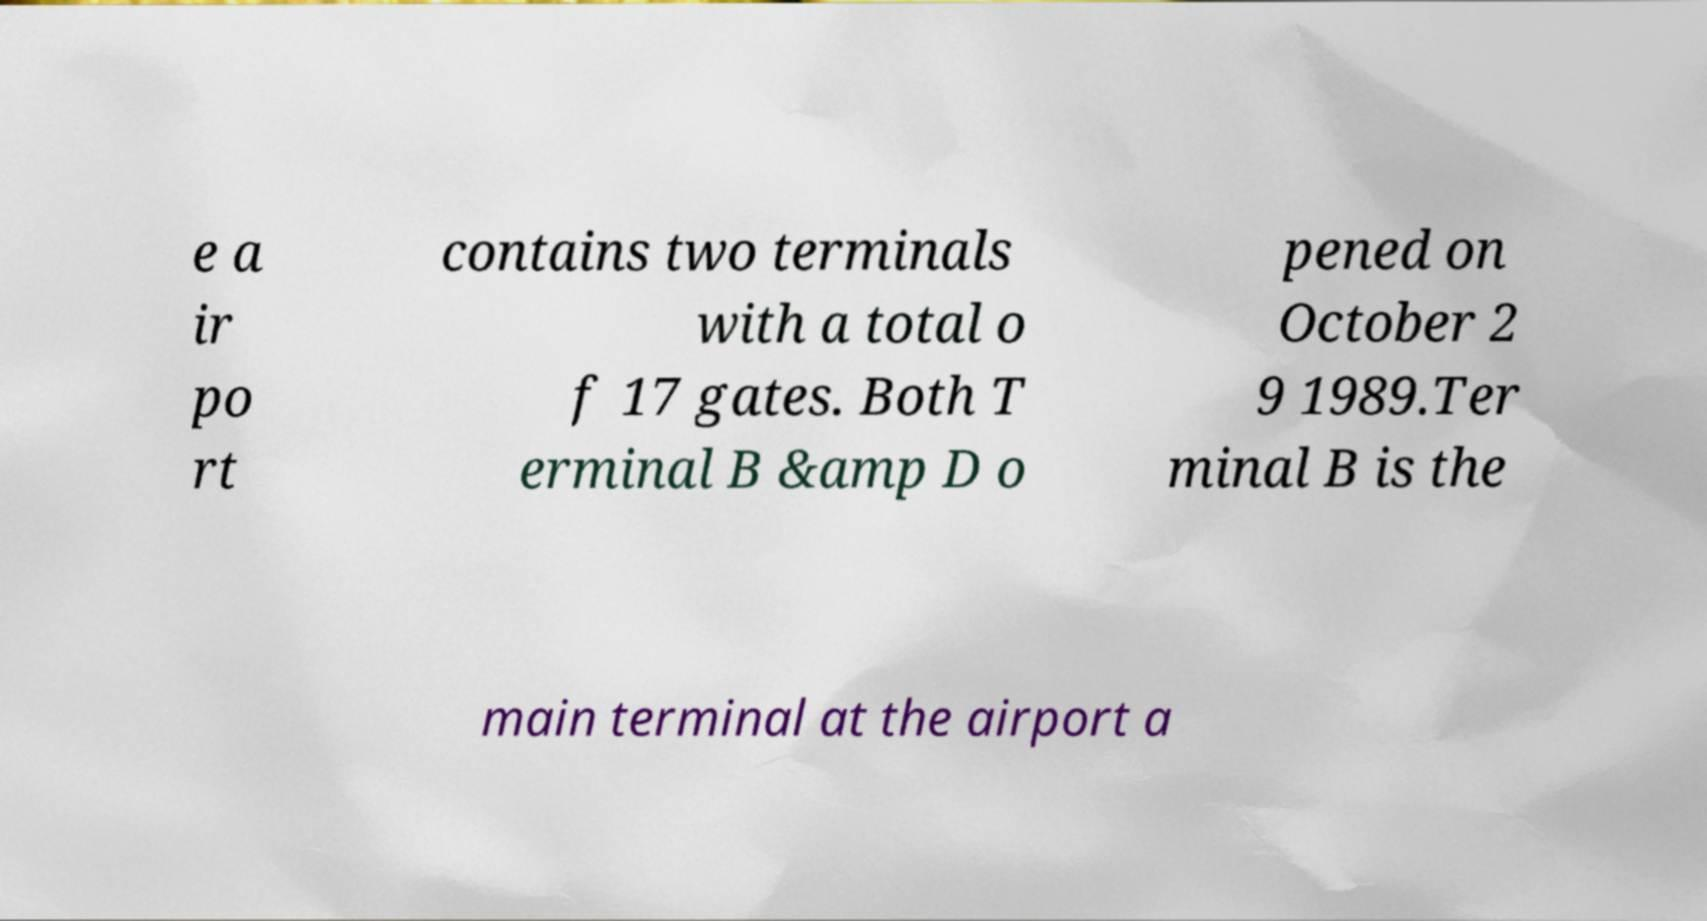Could you assist in decoding the text presented in this image and type it out clearly? e a ir po rt contains two terminals with a total o f 17 gates. Both T erminal B &amp D o pened on October 2 9 1989.Ter minal B is the main terminal at the airport a 